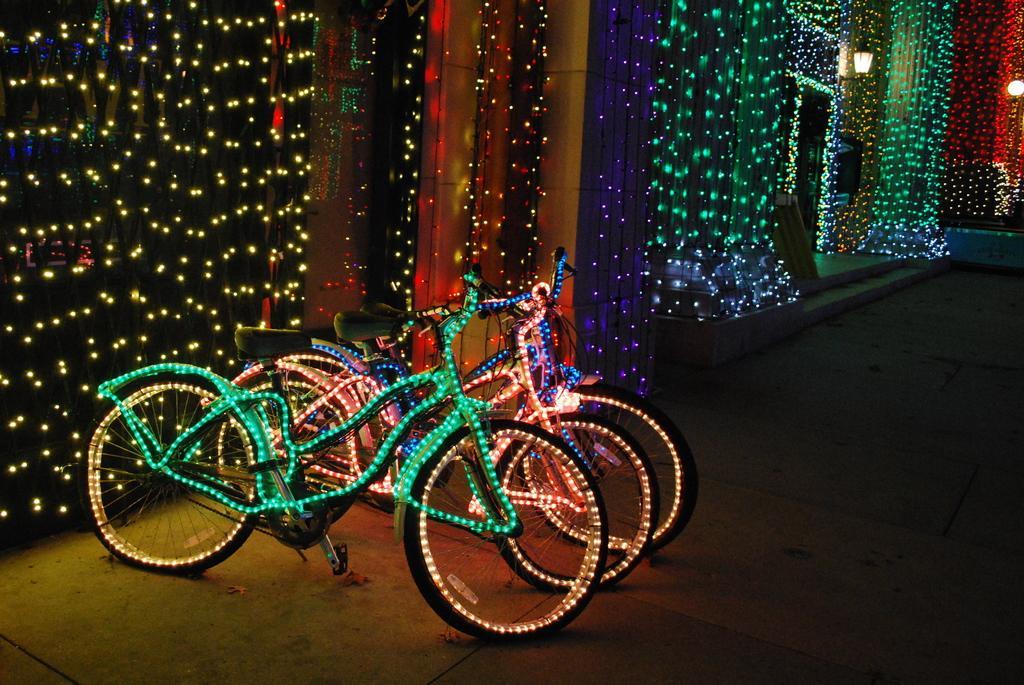Please provide a concise description of this image. In this image there are cycles to that cycles there is lighting, in the background there is wall for that wall there is lighting. 